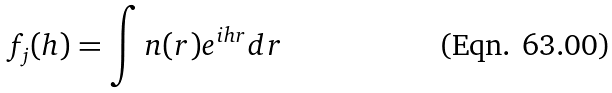<formula> <loc_0><loc_0><loc_500><loc_500>f _ { j } ( h ) = \int n ( r ) e ^ { i h r } d r</formula> 